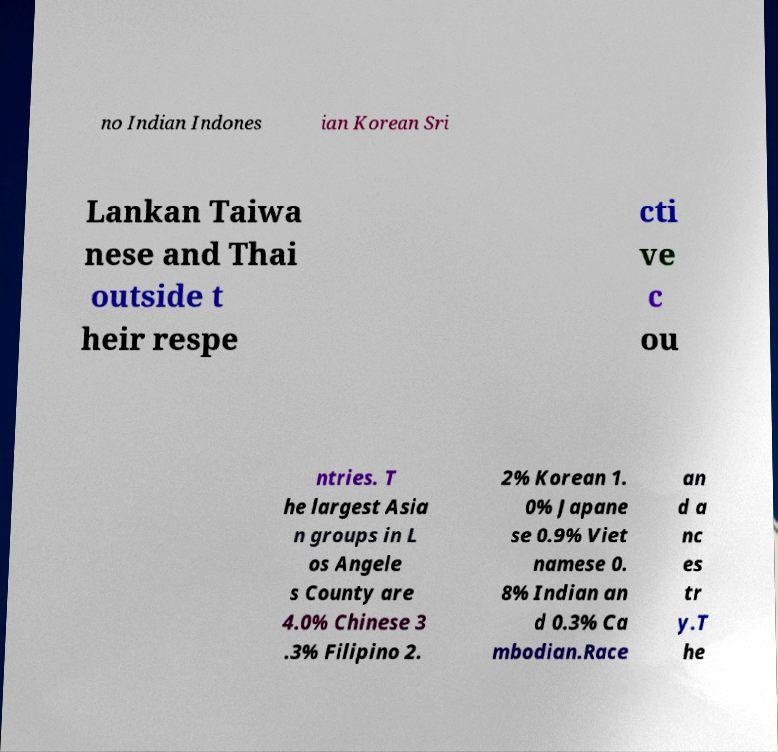I need the written content from this picture converted into text. Can you do that? no Indian Indones ian Korean Sri Lankan Taiwa nese and Thai outside t heir respe cti ve c ou ntries. T he largest Asia n groups in L os Angele s County are 4.0% Chinese 3 .3% Filipino 2. 2% Korean 1. 0% Japane se 0.9% Viet namese 0. 8% Indian an d 0.3% Ca mbodian.Race an d a nc es tr y.T he 